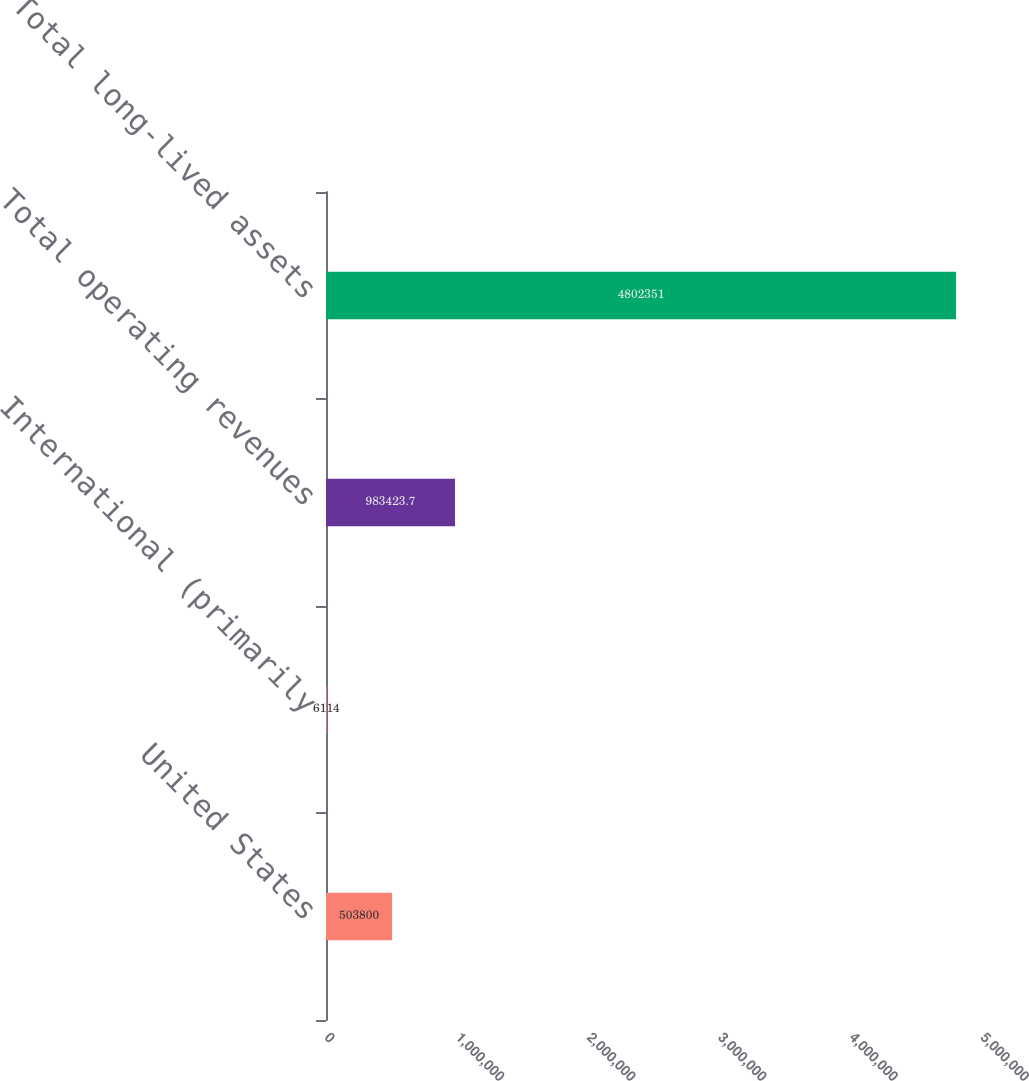<chart> <loc_0><loc_0><loc_500><loc_500><bar_chart><fcel>United States<fcel>International (primarily<fcel>Total operating revenues<fcel>Total long-lived assets<nl><fcel>503800<fcel>6114<fcel>983424<fcel>4.80235e+06<nl></chart> 